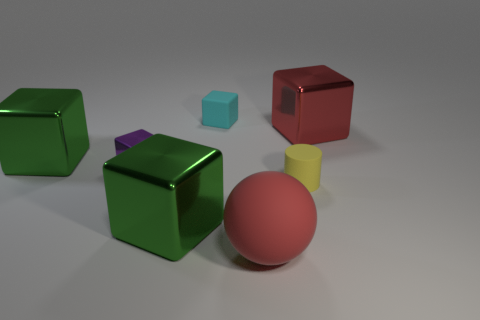Subtract 2 blocks. How many blocks are left? 3 Subtract all purple blocks. How many blocks are left? 4 Subtract all large red metallic cubes. How many cubes are left? 4 Subtract all green balls. Subtract all purple cylinders. How many balls are left? 1 Add 3 tiny yellow rubber things. How many objects exist? 10 Subtract all spheres. How many objects are left? 6 Add 4 blue rubber cubes. How many blue rubber cubes exist? 4 Subtract 1 red spheres. How many objects are left? 6 Subtract all large metallic spheres. Subtract all small cubes. How many objects are left? 5 Add 6 big red spheres. How many big red spheres are left? 7 